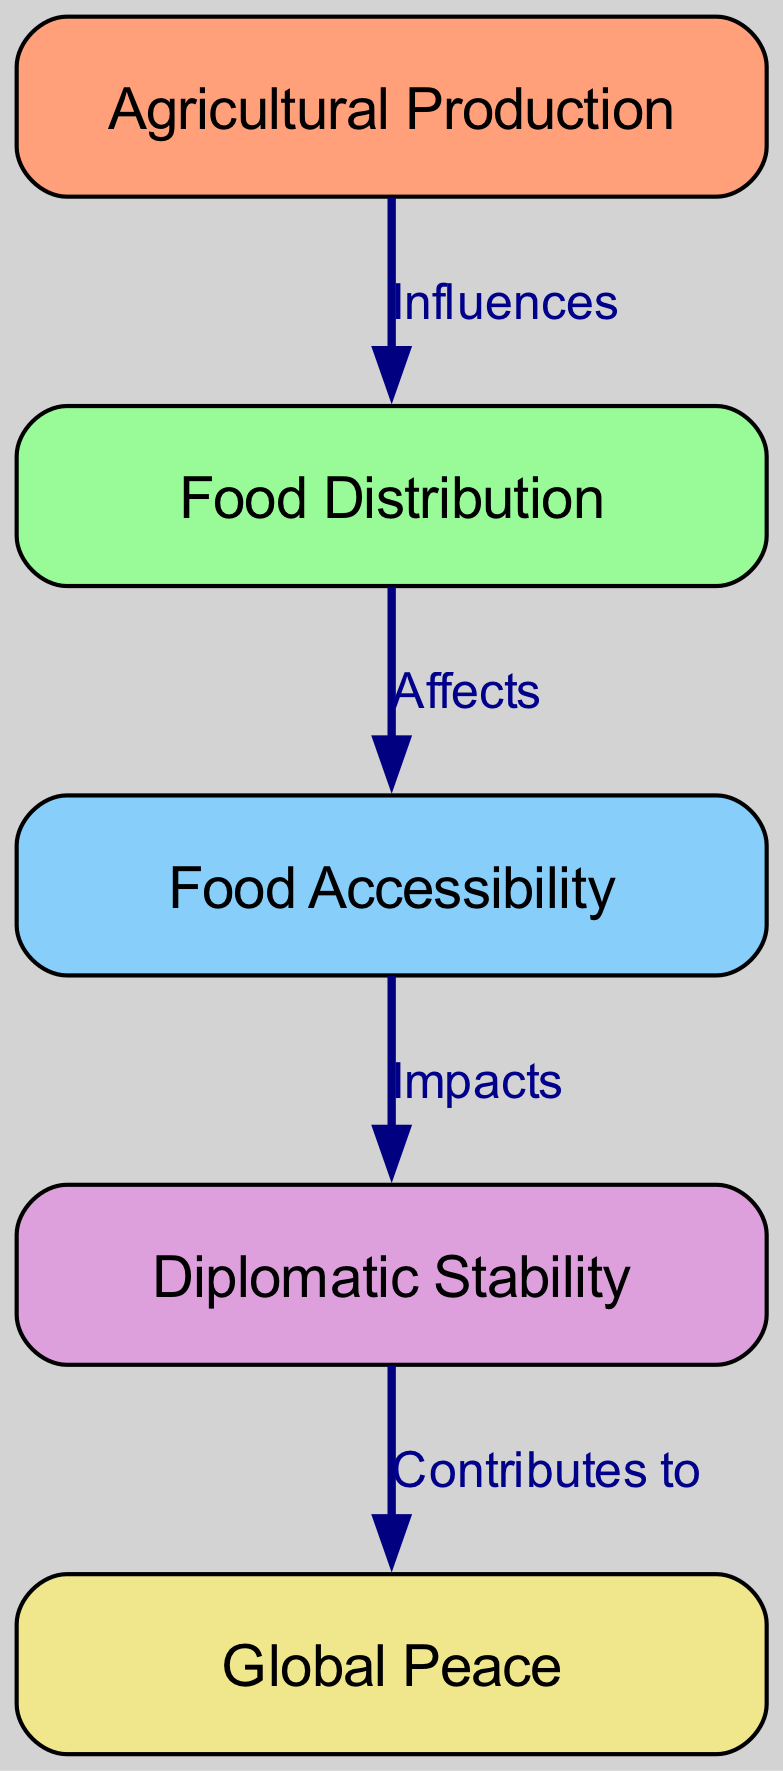What are the four main nodes shown in the diagram? The diagram includes four main nodes: Agricultural Production, Food Distribution, Food Accessibility, and Diplomatic Stability, each contributing to the overall concept of global peace.
Answer: Agricultural Production, Food Distribution, Food Accessibility, Diplomatic Stability How many edges are present in the diagram? The diagram consists of four edges that illustrate the relationships between the nodes: Influences, Affects, Impacts, and Contributes to.
Answer: Four Which node directly influences Food Distribution? According to the diagram, the node Agricultural Production directly influences Food Distribution, indicating that the quantity of food produced is a primary factor in how food is distributed.
Answer: Agricultural Production What does Food Accessibility impact? The diagram illustrates that Food Accessibility impacts Diplomatic Stability, suggesting that the ability of populations to access food is critical for maintaining stable diplomatic relations.
Answer: Diplomatic Stability What is the final outcome contributed to by Diplomatic Stability? The connection in the diagram shows that Diplomatic Stability contributes to Global Peace as its ultimate outcome, implying that stable diplomatic conditions help foster peaceful international relations.
Answer: Global Peace How do Food Distribution and Food Accessibility relate? The diagram indicates that Food Distribution affects Food Accessibility, meaning that how food is distributed plays a crucial role in whether people can access it effectively.
Answer: Affects What is the relationship type between Food Accessibility and Diplomatic Stability? The relationship type between Food Accessibility and Diplomatic Stability, as shown in the diagram, is "Impacts," indicating that changes in food accessibility have significant effects on diplomatic stability.
Answer: Impacts Which node serves as the starting point of the food chain? The starting point of the food chain in the diagram is Agricultural Production, highlighting that it is the initial factor that influences subsequent stages.
Answer: Agricultural Production How many types of relationships are depicted in the diagram? The diagram showcases four types of relationships, defined by the edges: Influences, Affects, Impacts, and Contributes to, representing different ways the nodes interact.
Answer: Four 